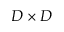<formula> <loc_0><loc_0><loc_500><loc_500>D \times D</formula> 